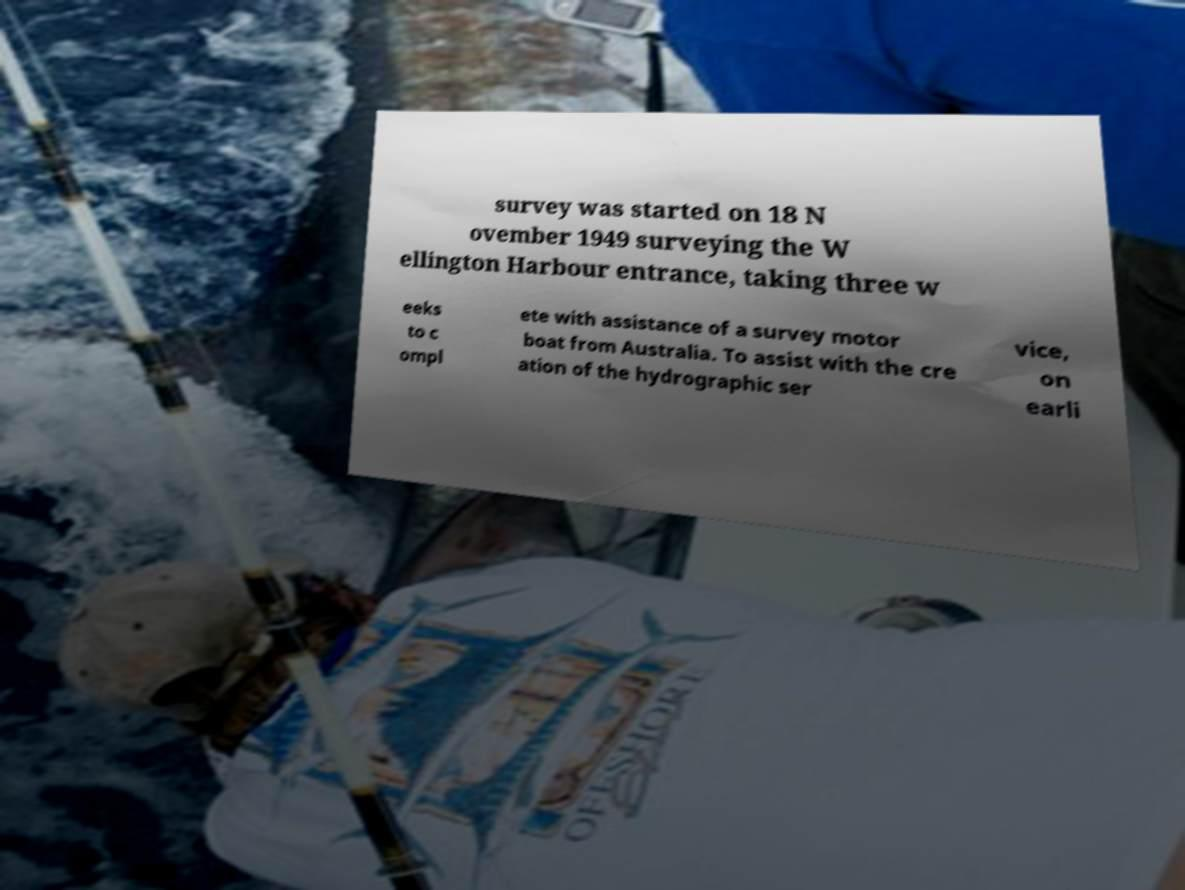Can you read and provide the text displayed in the image?This photo seems to have some interesting text. Can you extract and type it out for me? survey was started on 18 N ovember 1949 surveying the W ellington Harbour entrance, taking three w eeks to c ompl ete with assistance of a survey motor boat from Australia. To assist with the cre ation of the hydrographic ser vice, on earli 